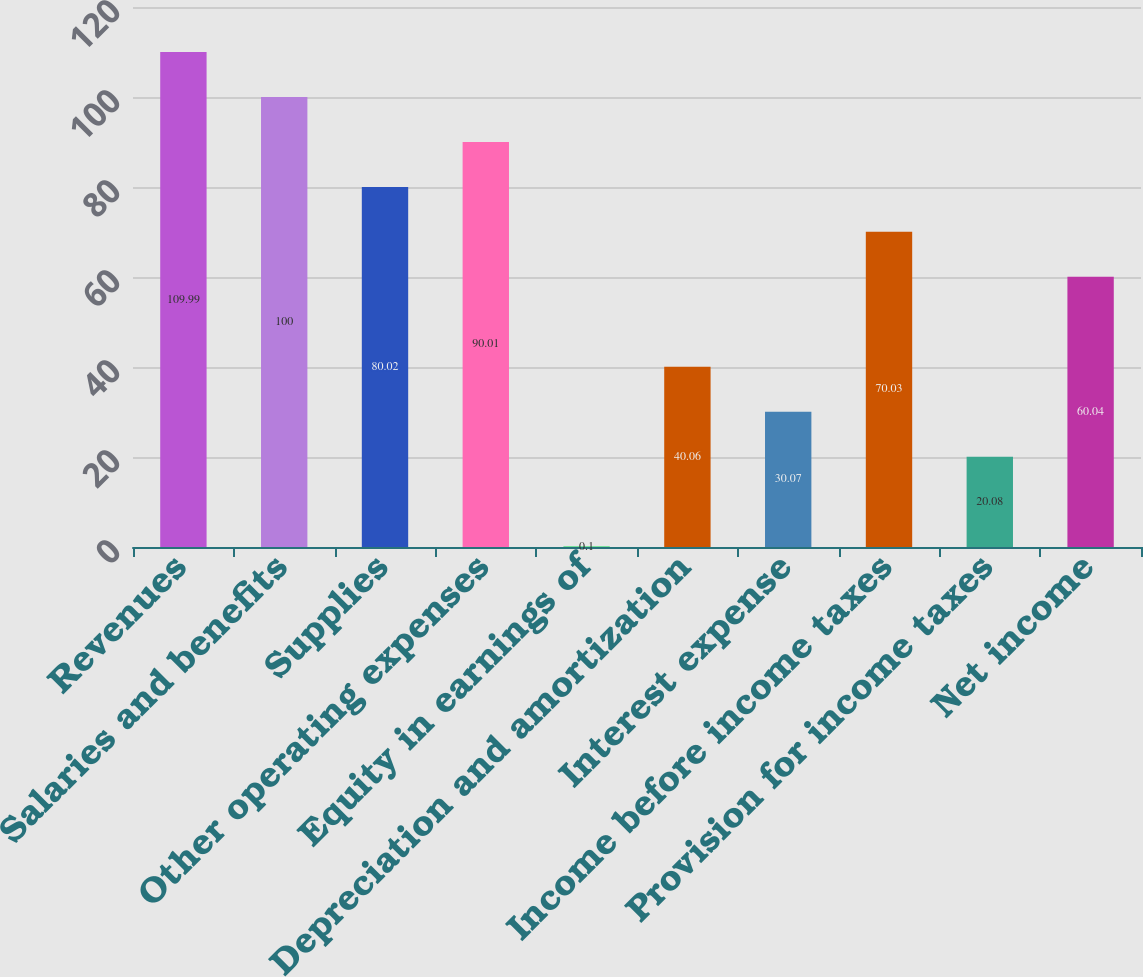Convert chart to OTSL. <chart><loc_0><loc_0><loc_500><loc_500><bar_chart><fcel>Revenues<fcel>Salaries and benefits<fcel>Supplies<fcel>Other operating expenses<fcel>Equity in earnings of<fcel>Depreciation and amortization<fcel>Interest expense<fcel>Income before income taxes<fcel>Provision for income taxes<fcel>Net income<nl><fcel>109.99<fcel>100<fcel>80.02<fcel>90.01<fcel>0.1<fcel>40.06<fcel>30.07<fcel>70.03<fcel>20.08<fcel>60.04<nl></chart> 